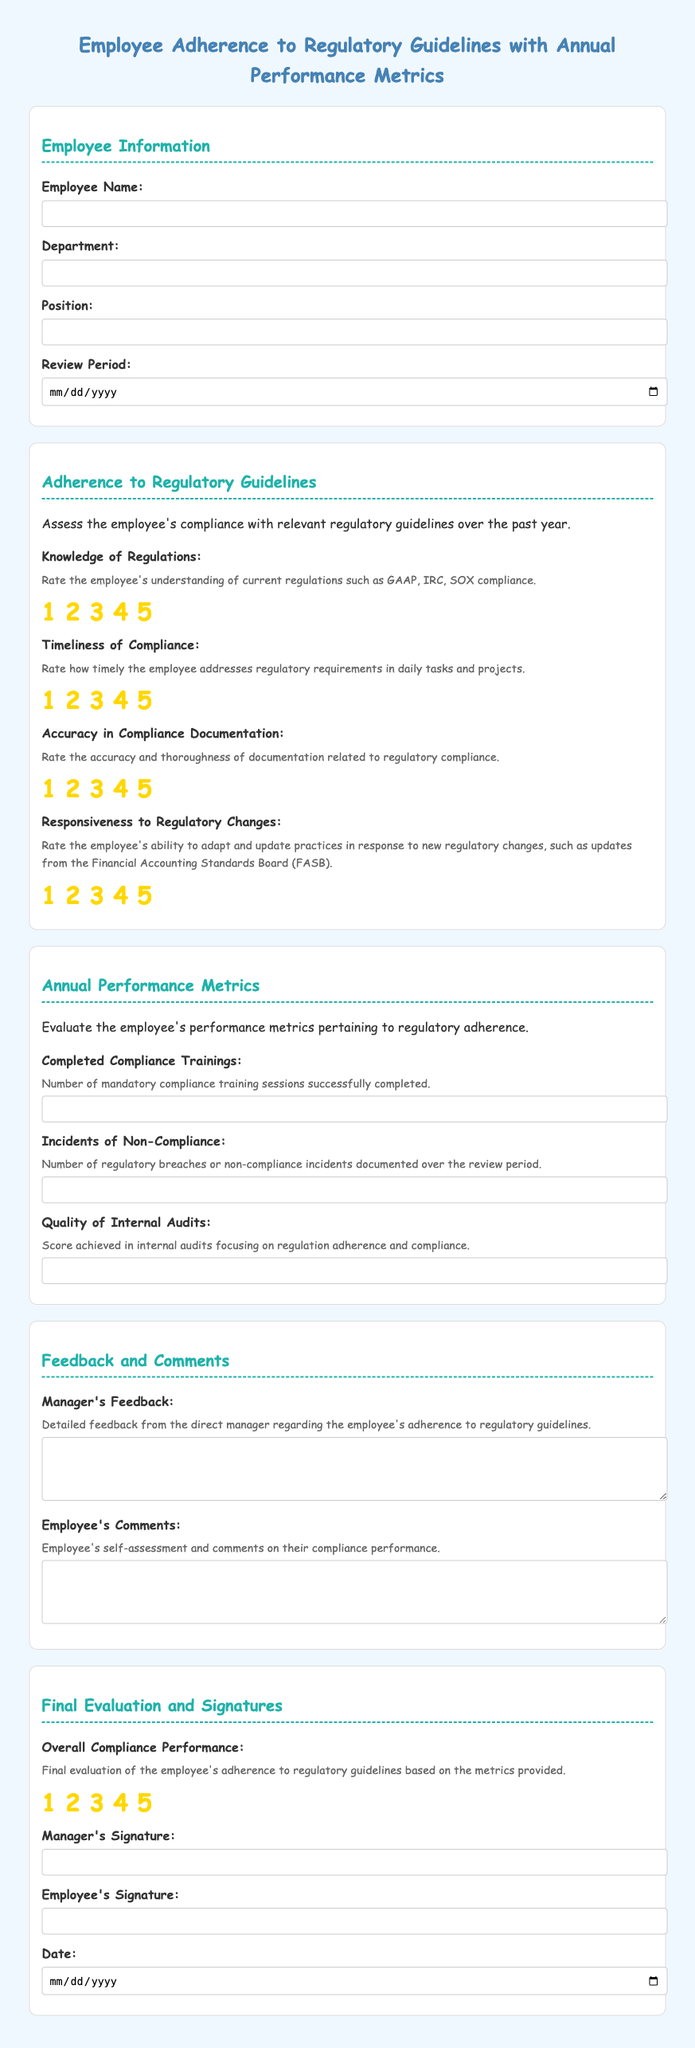What is the title of the document? The title is prominently displayed at the top of the document.
Answer: Employee Adherence to Regulatory Guidelines with Annual Performance Metrics Who should provide the manager's feedback? The manager is the one responsible for providing feedback on the employee's performance.
Answer: Direct manager How many ratings categories are there under "Adherence to Regulatory Guidelines"? The document lists five different criteria for ratings in this section.
Answer: Four What is the purpose of the "Annual Performance Metrics" section? This section evaluates the employee's performance metrics regarding regulatory adherence.
Answer: Evaluate performance metrics What can be found in the "Completed Compliance Trainings" field? This field requires the input of a numerical value representing training sessions.
Answer: Number of sessions What is the field asking for in "Incidents of Non-Compliance"? This field captures how many regulatory breaches occurred during the review period.
Answer: Number of incidents What is the total rating scale used in the document? The ratings are on a scale from one to five, with five being the highest.
Answer: One to five Who needs to sign the evaluation? The document specifies that both the manager and the employee must provide signatures.
Answer: Manager and employee 